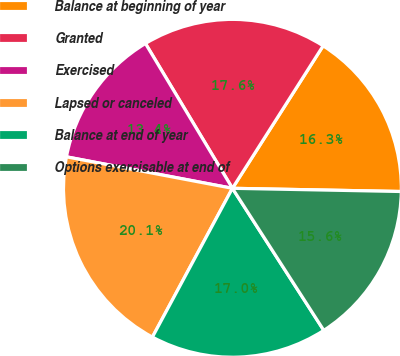Convert chart to OTSL. <chart><loc_0><loc_0><loc_500><loc_500><pie_chart><fcel>Balance at beginning of year<fcel>Granted<fcel>Exercised<fcel>Lapsed or canceled<fcel>Balance at end of year<fcel>Options exercisable at end of<nl><fcel>16.28%<fcel>17.63%<fcel>13.41%<fcel>20.13%<fcel>16.95%<fcel>15.6%<nl></chart> 